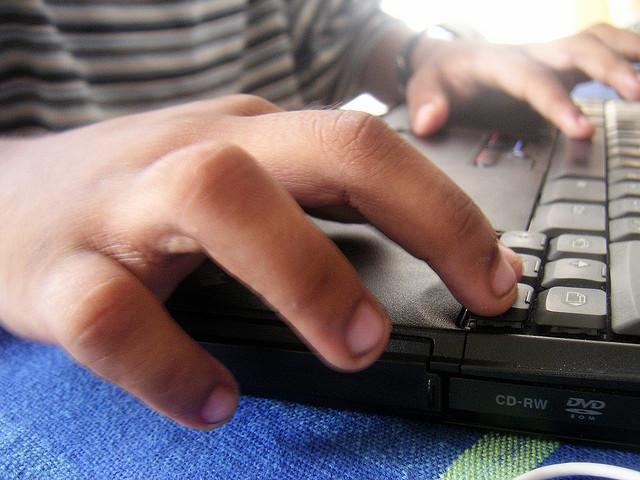How many black cups are there?
Give a very brief answer. 0. 